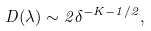<formula> <loc_0><loc_0><loc_500><loc_500>D ( \lambda ) \sim 2 \delta ^ { - K - 1 / 2 } ,</formula> 